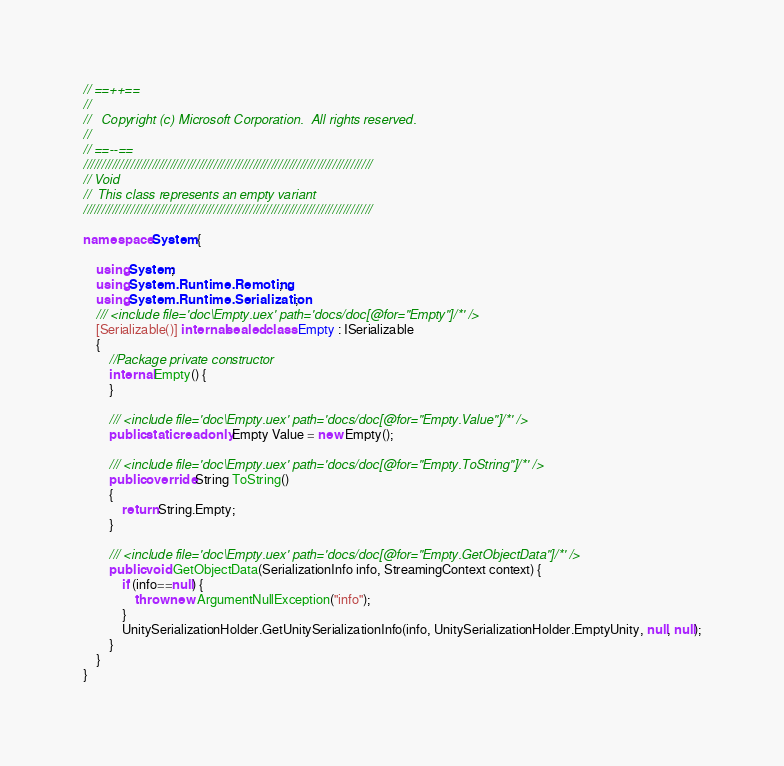<code> <loc_0><loc_0><loc_500><loc_500><_C#_>// ==++==
// 
//   Copyright (c) Microsoft Corporation.  All rights reserved.
// 
// ==--==
////////////////////////////////////////////////////////////////////////////////
// Void
//	This class represents an empty variant
////////////////////////////////////////////////////////////////////////////////

namespace System {
    
	using System;
	using System.Runtime.Remoting;
	using System.Runtime.Serialization;
    /// <include file='doc\Empty.uex' path='docs/doc[@for="Empty"]/*' />
    [Serializable()] internal sealed class Empty : ISerializable
    {
        //Package private constructor
        internal Empty() {
        }
    
    	/// <include file='doc\Empty.uex' path='docs/doc[@for="Empty.Value"]/*' />
    	public static readonly Empty Value = new Empty();
    	
    	/// <include file='doc\Empty.uex' path='docs/doc[@for="Empty.ToString"]/*' />
    	public override String ToString()
    	{
    		return String.Empty;
    	}
    
        /// <include file='doc\Empty.uex' path='docs/doc[@for="Empty.GetObjectData"]/*' />
        public void GetObjectData(SerializationInfo info, StreamingContext context) {
            if (info==null) {
                throw new ArgumentNullException("info");
            }
            UnitySerializationHolder.GetUnitySerializationInfo(info, UnitySerializationHolder.EmptyUnity, null, null);
        }
    }
}
</code> 